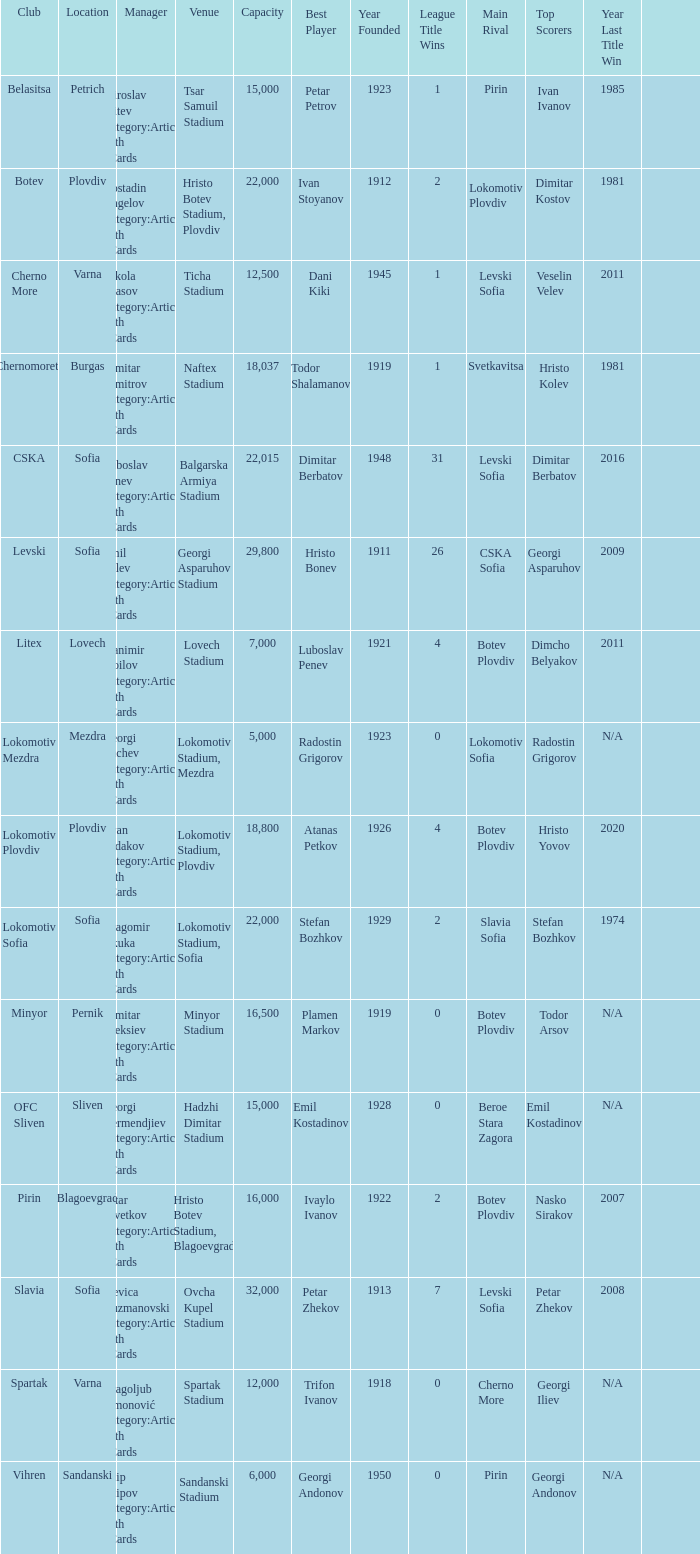What is the highest capacity for the venue, ticha stadium, located in varna? 12500.0. 